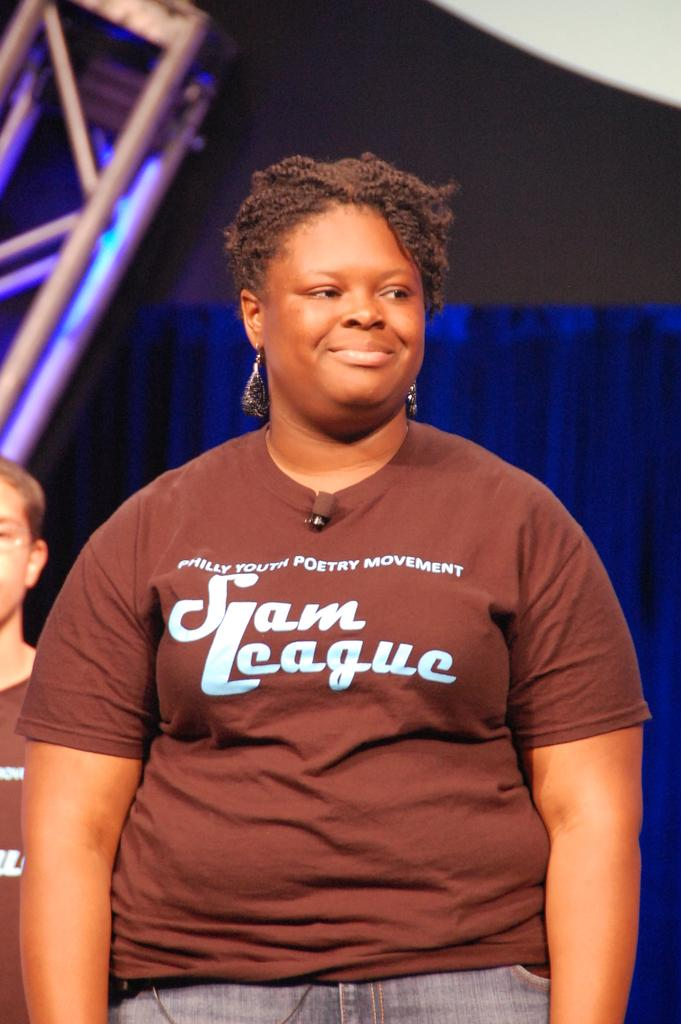<image>
Provide a brief description of the given image. A member of a Philadelphia poetry league wears her club's t-shirt. 